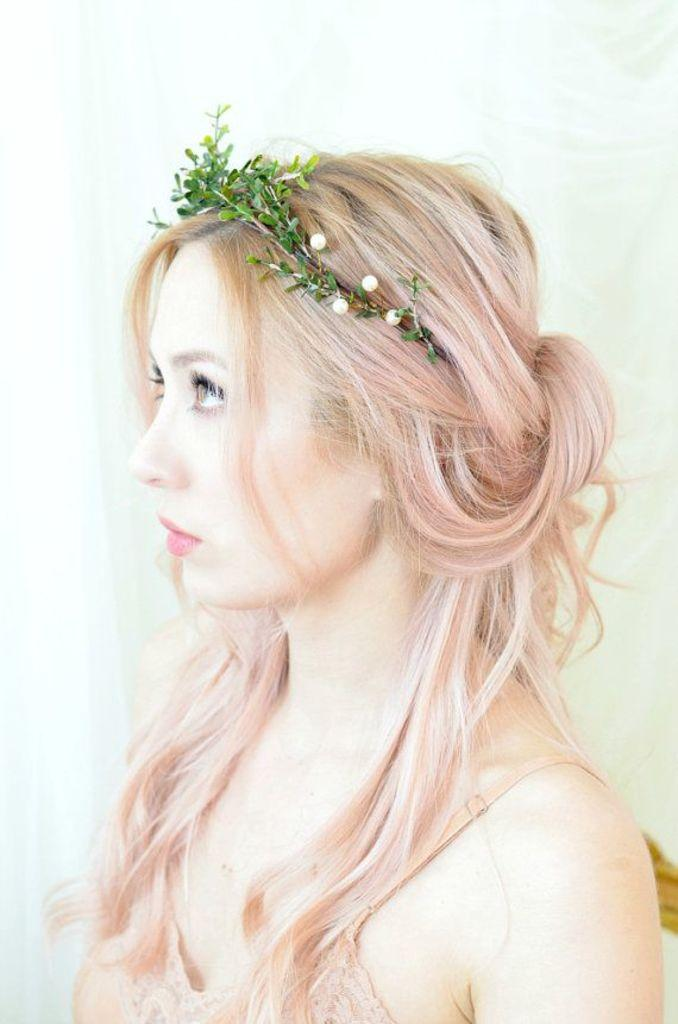Who is present in the image? There is a woman in the image. What is the woman wearing on her head? The woman is wearing a ring made up of leaves, which is also known as a hair band. How many men are present in the image? There are no men present in the image; only a woman is visible. What type of fowl can be seen in the image? There is no fowl present in the image. 